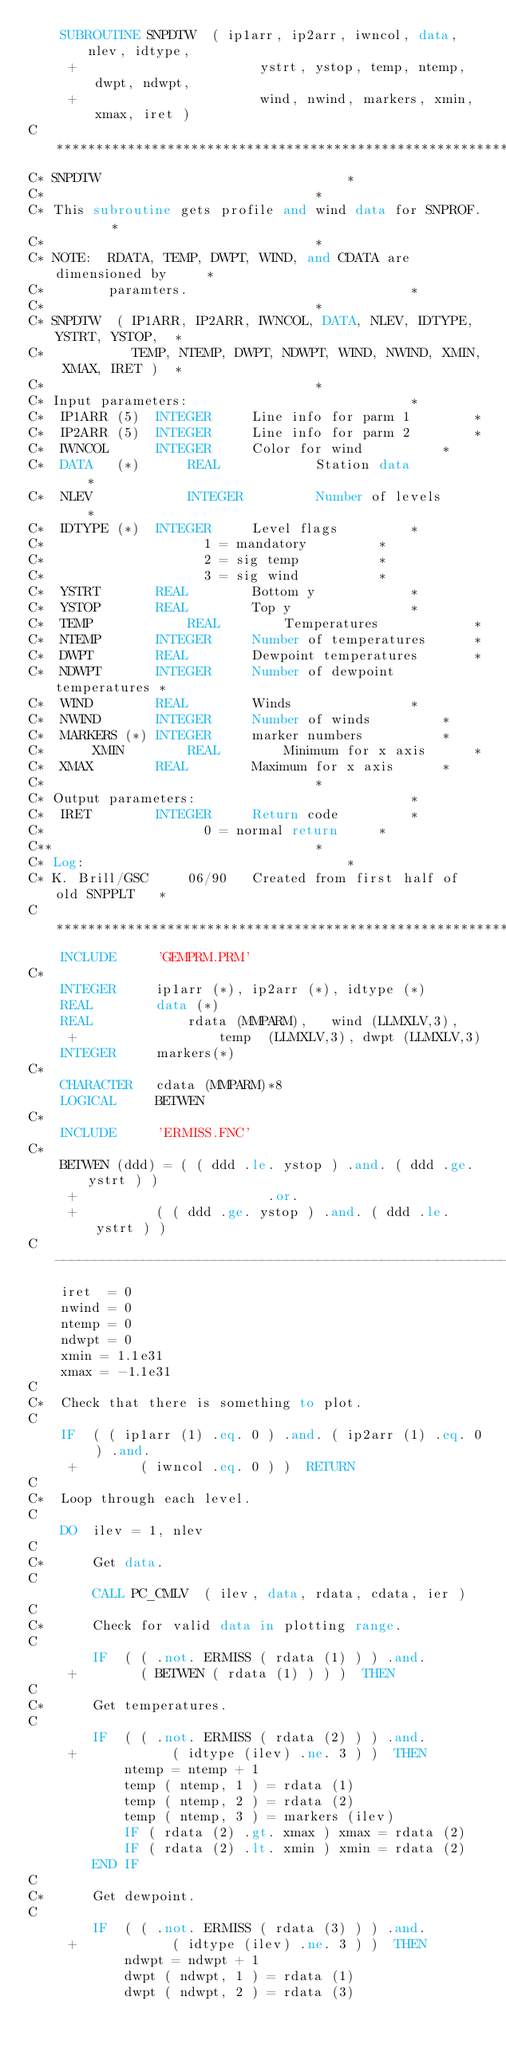<code> <loc_0><loc_0><loc_500><loc_500><_FORTRAN_>	SUBROUTINE SNPDTW  ( ip1arr, ip2arr, iwncol, data, nlev, idtype,
     +                       ystrt, ystop, temp, ntemp, dwpt, ndwpt,
     +                       wind, nwind, markers, xmin, xmax, iret )
C************************************************************************
C* SNPDTW								*
C*									*
C* This subroutine gets profile and wind data for SNPROF.		*
C*									*
C* NOTE:  RDATA, TEMP, DWPT, WIND, and CDATA are dimensioned by		*
C*        paramters.							*
C*									*
C* SNPDTW  ( IP1ARR, IP2ARR, IWNCOL, DATA, NLEV, IDTYPE, YSTRT, YSTOP,	*
C*           TEMP, NTEMP, DWPT, NDWPT, WIND, NWIND, XMIN, XMAX, IRET )	*
C*									*
C* Input parameters:							*
C*	IP1ARR (5)	INTEGER		Line info for parm 1		*
C*	IP2ARR (5)	INTEGER		Line info for parm 2		*
C*	IWNCOL		INTEGER		Color for wind			*
C*	DATA   (*)      REAL            Station data			*
C*	NLEV            INTEGER         Number of levels		*
C*	IDTYPE (*)	INTEGER		Level flags			*
C*					  1 = mandatory			*
C*					  2 = sig temp			*
C*					  3 = sig wind			*
C*	YSTRT		REAL		Bottom y			*
C*	YSTOP		REAL		Top y				*
C*	TEMP            REAL		Temperatures			*
C*	NTEMP		INTEGER		Number of temperatures		*
C*	DWPT		REAL		Dewpoint temperatures		*
C*	NDWPT		INTEGER		Number of dewpoint temperatures	*
C*	WIND		REAL		Winds				*
C*	NWIND		INTEGER		Number of winds			*
C*	MARKERS	(*)	INTEGER		marker numbers			*
C*      XMIN		REAL		Minimum for x axis		*
C*	XMAX		REAL		Maximum for x axis		*
C*									*
C* Output parameters:							*
C*	IRET		INTEGER		Return code			*
C*					  0 = normal return		*
C**									*
C* Log:									*
C* K. Brill/GSC		06/90	Created from first half of old SNPPLT	*
C************************************************************************
	INCLUDE		'GEMPRM.PRM'
C*
	INTEGER		ip1arr (*), ip2arr (*), idtype (*)
	REAL		data (*)
	REAL            rdata (MMPARM),   wind (LLMXLV,3),
     +                  temp  (LLMXLV,3), dwpt (LLMXLV,3)
	INTEGER		markers(*)
C*
	CHARACTER	cdata (MMPARM)*8
	LOGICAL		BETWEN
C*
	INCLUDE		'ERMISS.FNC'
C*
	BETWEN (ddd) = ( ( ddd .le. ystop ) .and. ( ddd .ge. ystrt ) )
     +					      .or.
     +			( ( ddd .ge. ystop ) .and. ( ddd .le. ystrt ) )
C----------------------------------------------------------------------
	iret  = 0
	nwind = 0
	ntemp = 0
	ndwpt = 0
	xmin = 1.1e31
	xmax = -1.1e31
C
C*	Check that there is something to plot.
C
	IF  ( ( ip1arr (1) .eq. 0 ) .and. ( ip2arr (1) .eq. 0 ) .and.
     +	      ( iwncol .eq. 0 ) )  RETURN
C
C*	Loop through each level.
C
	DO  ilev = 1, nlev
C
C*	    Get data.
C
	    CALL PC_CMLV  ( ilev, data, rdata, cdata, ier )
C
C*	    Check for valid data in plotting range.
C
	    IF  ( ( .not. ERMISS ( rdata (1) ) ) .and. 
     +		  ( BETWEN ( rdata (1) ) ) )  THEN
C
C*		Get temperatures.
C
		IF  ( ( .not. ERMISS ( rdata (2) ) ) .and.
     +		      ( idtype (ilev) .ne. 3 ) )  THEN
		    ntemp = ntemp + 1
		    temp ( ntemp, 1 ) = rdata (1)
		    temp ( ntemp, 2 ) = rdata (2)
		    temp ( ntemp, 3 ) = markers (ilev)
		    IF ( rdata (2) .gt. xmax ) xmax = rdata (2)
	  	    IF ( rdata (2) .lt. xmin ) xmin = rdata (2)
		END IF
C
C*		Get dewpoint.
C
		IF  ( ( .not. ERMISS ( rdata (3) ) ) .and. 
     +		      ( idtype (ilev) .ne. 3 ) )  THEN
		    ndwpt = ndwpt + 1
		    dwpt ( ndwpt, 1 ) = rdata (1)
		    dwpt ( ndwpt, 2 ) = rdata (3)</code> 